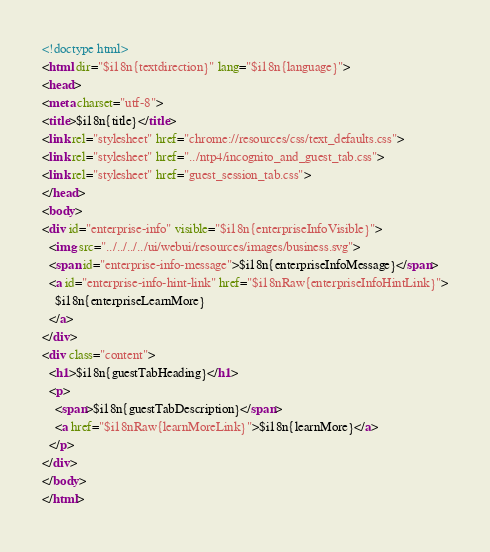Convert code to text. <code><loc_0><loc_0><loc_500><loc_500><_HTML_><!doctype html>
<html dir="$i18n{textdirection}" lang="$i18n{language}">
<head>
<meta charset="utf-8">
<title>$i18n{title}</title>
<link rel="stylesheet" href="chrome://resources/css/text_defaults.css">
<link rel="stylesheet" href="../ntp4/incognito_and_guest_tab.css">
<link rel="stylesheet" href="guest_session_tab.css">
</head>
<body>
<div id="enterprise-info" visible="$i18n{enterpriseInfoVisible}">
  <img src="../../../../ui/webui/resources/images/business.svg">
  <span id="enterprise-info-message">$i18n{enterpriseInfoMessage}</span>
  <a id="enterprise-info-hint-link" href="$i18nRaw{enterpriseInfoHintLink}">
    $i18n{enterpriseLearnMore}
  </a>
</div>
<div class="content">
  <h1>$i18n{guestTabHeading}</h1>
  <p>
    <span>$i18n{guestTabDescription}</span>
    <a href="$i18nRaw{learnMoreLink}">$i18n{learnMore}</a>
  </p>
</div>
</body>
</html>
</code> 